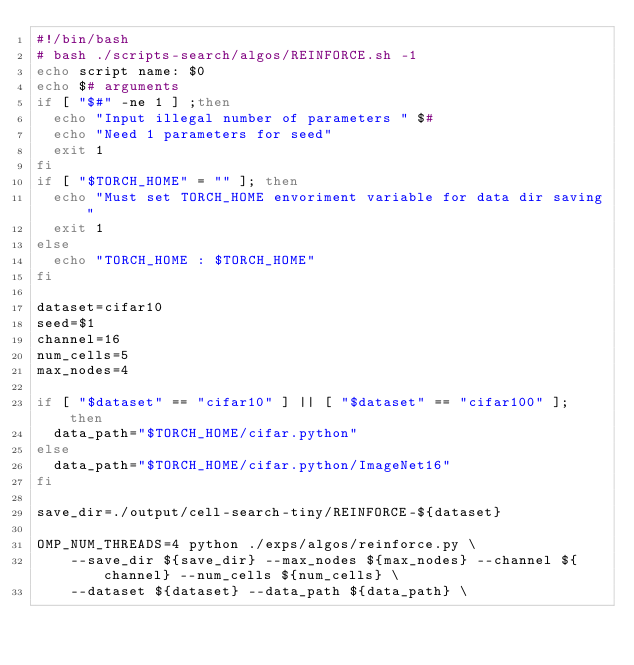<code> <loc_0><loc_0><loc_500><loc_500><_Bash_>#!/bin/bash
# bash ./scripts-search/algos/REINFORCE.sh -1
echo script name: $0
echo $# arguments
if [ "$#" -ne 1 ] ;then
  echo "Input illegal number of parameters " $#
  echo "Need 1 parameters for seed"
  exit 1
fi
if [ "$TORCH_HOME" = "" ]; then
  echo "Must set TORCH_HOME envoriment variable for data dir saving"
  exit 1
else
  echo "TORCH_HOME : $TORCH_HOME"
fi

dataset=cifar10
seed=$1
channel=16
num_cells=5
max_nodes=4

if [ "$dataset" == "cifar10" ] || [ "$dataset" == "cifar100" ]; then
  data_path="$TORCH_HOME/cifar.python"
else
  data_path="$TORCH_HOME/cifar.python/ImageNet16"
fi

save_dir=./output/cell-search-tiny/REINFORCE-${dataset}

OMP_NUM_THREADS=4 python ./exps/algos/reinforce.py \
	--save_dir ${save_dir} --max_nodes ${max_nodes} --channel ${channel} --num_cells ${num_cells} \
	--dataset ${dataset} --data_path ${data_path} \</code> 